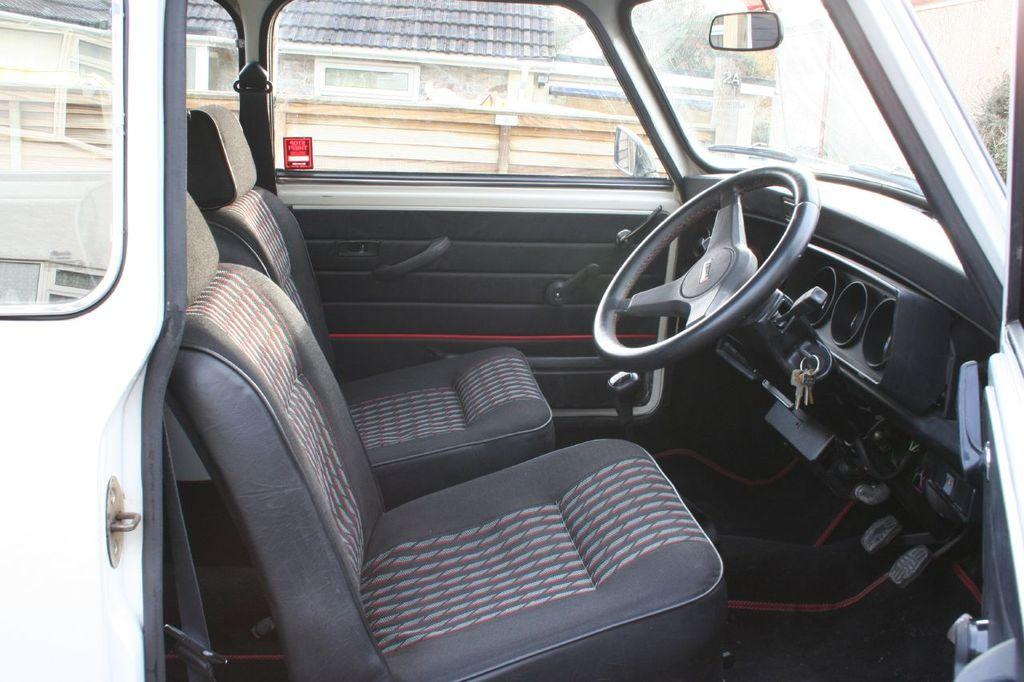What is the main object in the image? There is a vehicle in the image. What is the state of the vehicle's door? The door of the vehicle is opened. What can be seen through the glass of the vehicle? A house and a wall are visible through the glass of the vehicle. How many deer can be seen in the image? There are no deer present in the image. 